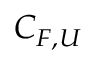Convert formula to latex. <formula><loc_0><loc_0><loc_500><loc_500>C _ { F , U }</formula> 